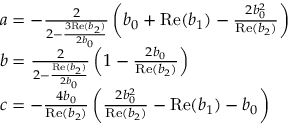Convert formula to latex. <formula><loc_0><loc_0><loc_500><loc_500>\begin{array} { r l } & { a = - \frac { 2 } { 2 - \frac { 3 R e ( b _ { 2 } ) } { 2 b _ { 0 } } } \left ( b _ { 0 } + R e ( b _ { 1 } ) - \frac { 2 b _ { 0 } ^ { 2 } } { R e ( b _ { 2 } ) } \right ) } \\ & { b = \frac { 2 } { 2 - \frac { R e ( b _ { 2 } ) } { 2 b _ { 0 } } } \left ( 1 - \frac { 2 b _ { 0 } } { R e ( b _ { 2 } ) } \right ) } \\ & { c = - \frac { 4 b _ { 0 } } { R e ( b _ { 2 } ) } \left ( \frac { 2 b _ { 0 } ^ { 2 } } { R e ( b _ { 2 } ) } - R e ( b _ { 1 } ) - b _ { 0 } \right ) } \end{array}</formula> 